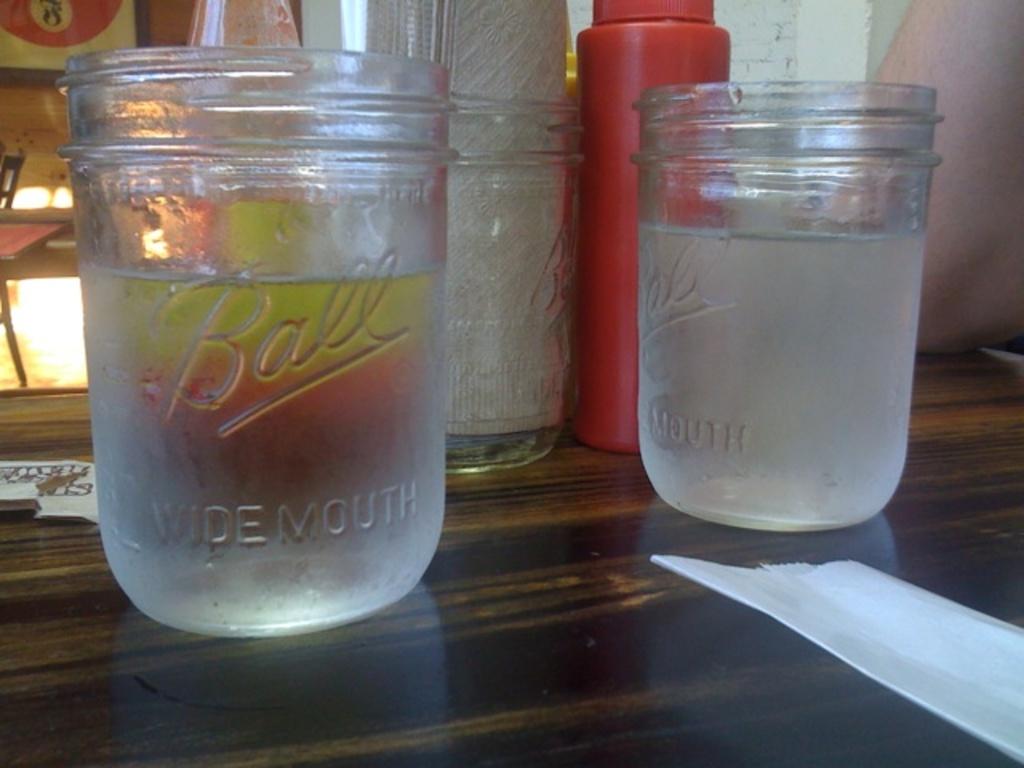What is the brand of these jar cups?
Provide a short and direct response. Ball. What is written under ball?
Provide a short and direct response. Wide mouth. 